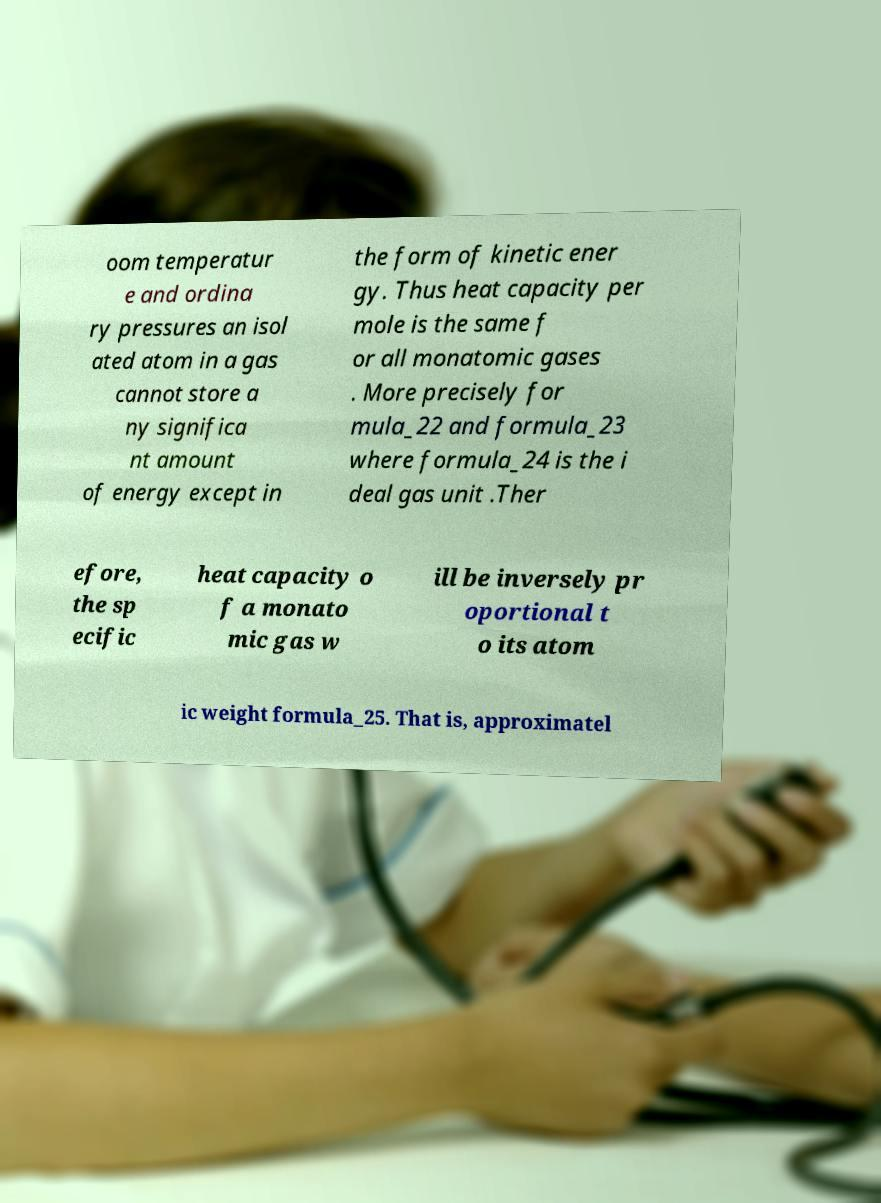Please read and relay the text visible in this image. What does it say? oom temperatur e and ordina ry pressures an isol ated atom in a gas cannot store a ny significa nt amount of energy except in the form of kinetic ener gy. Thus heat capacity per mole is the same f or all monatomic gases . More precisely for mula_22 and formula_23 where formula_24 is the i deal gas unit .Ther efore, the sp ecific heat capacity o f a monato mic gas w ill be inversely pr oportional t o its atom ic weight formula_25. That is, approximatel 